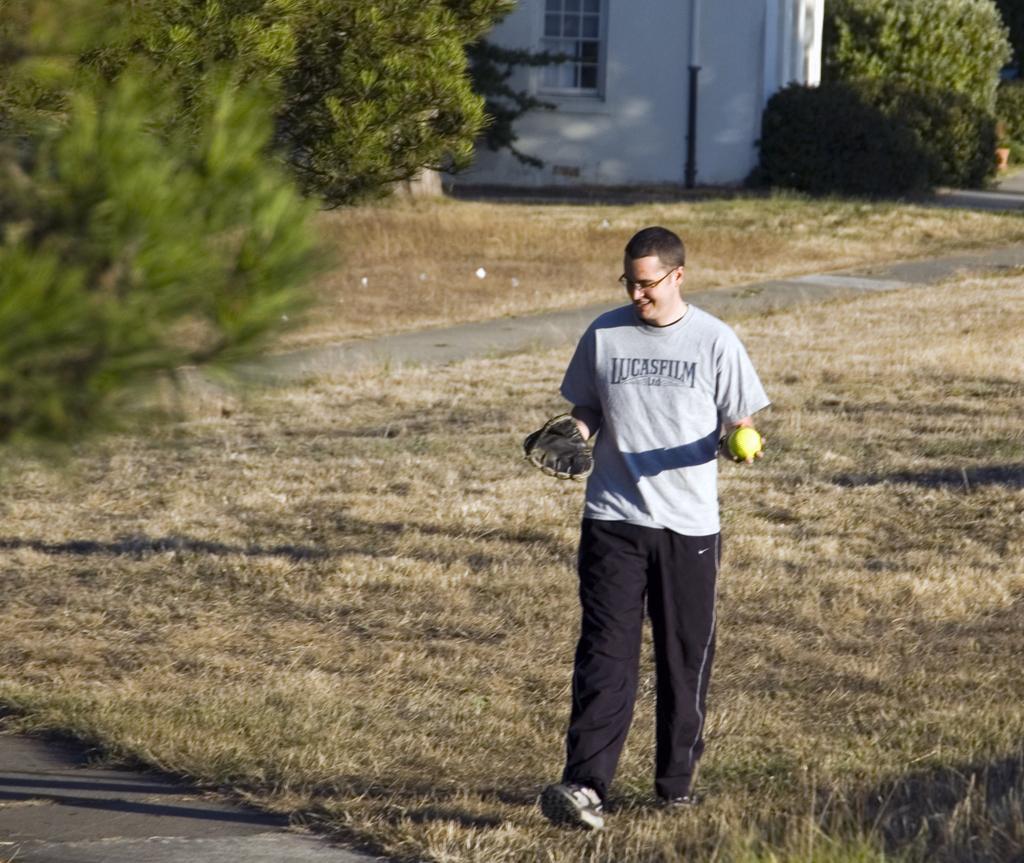In one or two sentences, can you explain what this image depicts? In this image there is a man walking on the ground by holding the ball with one hand and a glove with another hand. In the background there is a building. There are trees around the building. On the ground there is grass. 